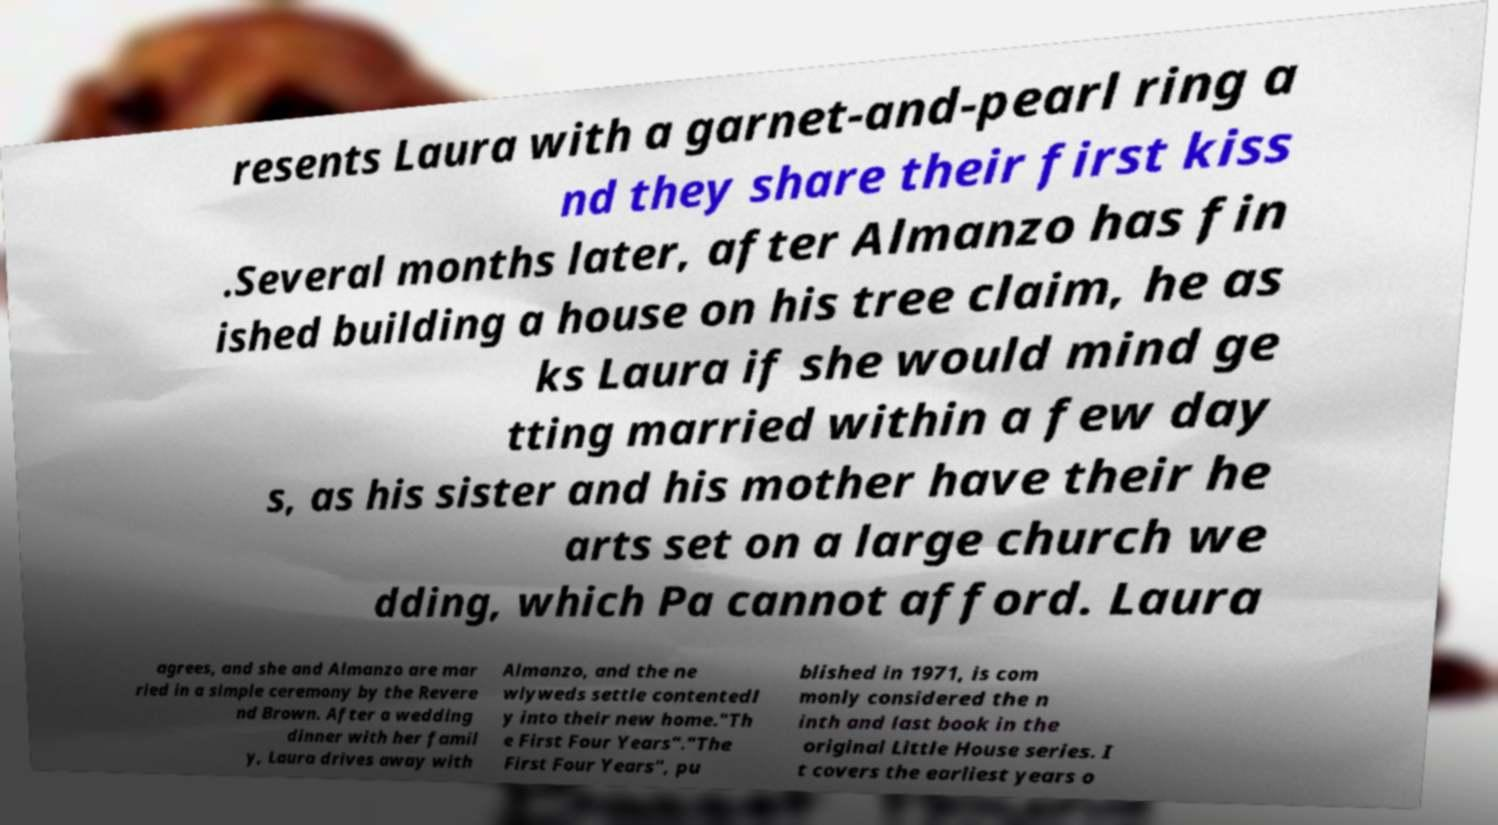What messages or text are displayed in this image? I need them in a readable, typed format. resents Laura with a garnet-and-pearl ring a nd they share their first kiss .Several months later, after Almanzo has fin ished building a house on his tree claim, he as ks Laura if she would mind ge tting married within a few day s, as his sister and his mother have their he arts set on a large church we dding, which Pa cannot afford. Laura agrees, and she and Almanzo are mar ried in a simple ceremony by the Revere nd Brown. After a wedding dinner with her famil y, Laura drives away with Almanzo, and the ne wlyweds settle contentedl y into their new home."Th e First Four Years"."The First Four Years", pu blished in 1971, is com monly considered the n inth and last book in the original Little House series. I t covers the earliest years o 